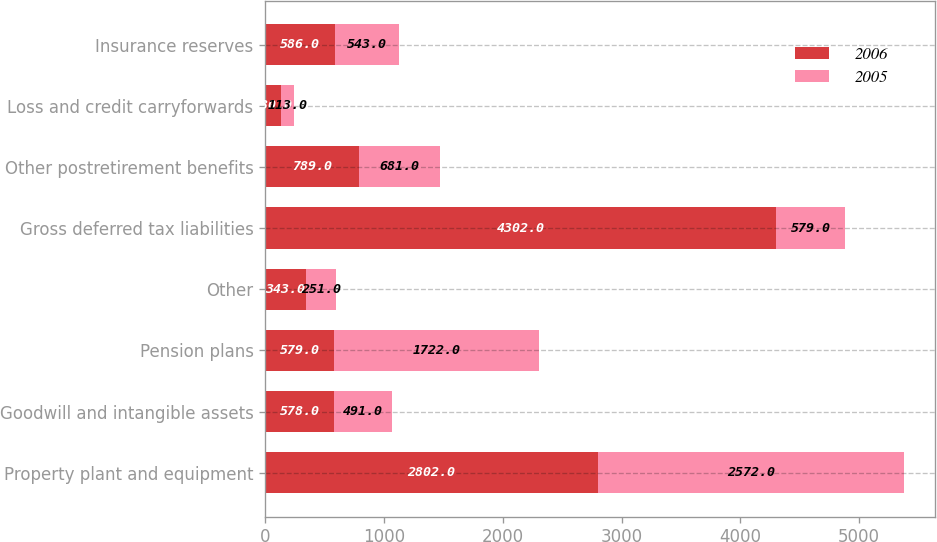Convert chart. <chart><loc_0><loc_0><loc_500><loc_500><stacked_bar_chart><ecel><fcel>Property plant and equipment<fcel>Goodwill and intangible assets<fcel>Pension plans<fcel>Other<fcel>Gross deferred tax liabilities<fcel>Other postretirement benefits<fcel>Loss and credit carryforwards<fcel>Insurance reserves<nl><fcel>2006<fcel>2802<fcel>578<fcel>579<fcel>343<fcel>4302<fcel>789<fcel>130<fcel>586<nl><fcel>2005<fcel>2572<fcel>491<fcel>1722<fcel>251<fcel>579<fcel>681<fcel>113<fcel>543<nl></chart> 